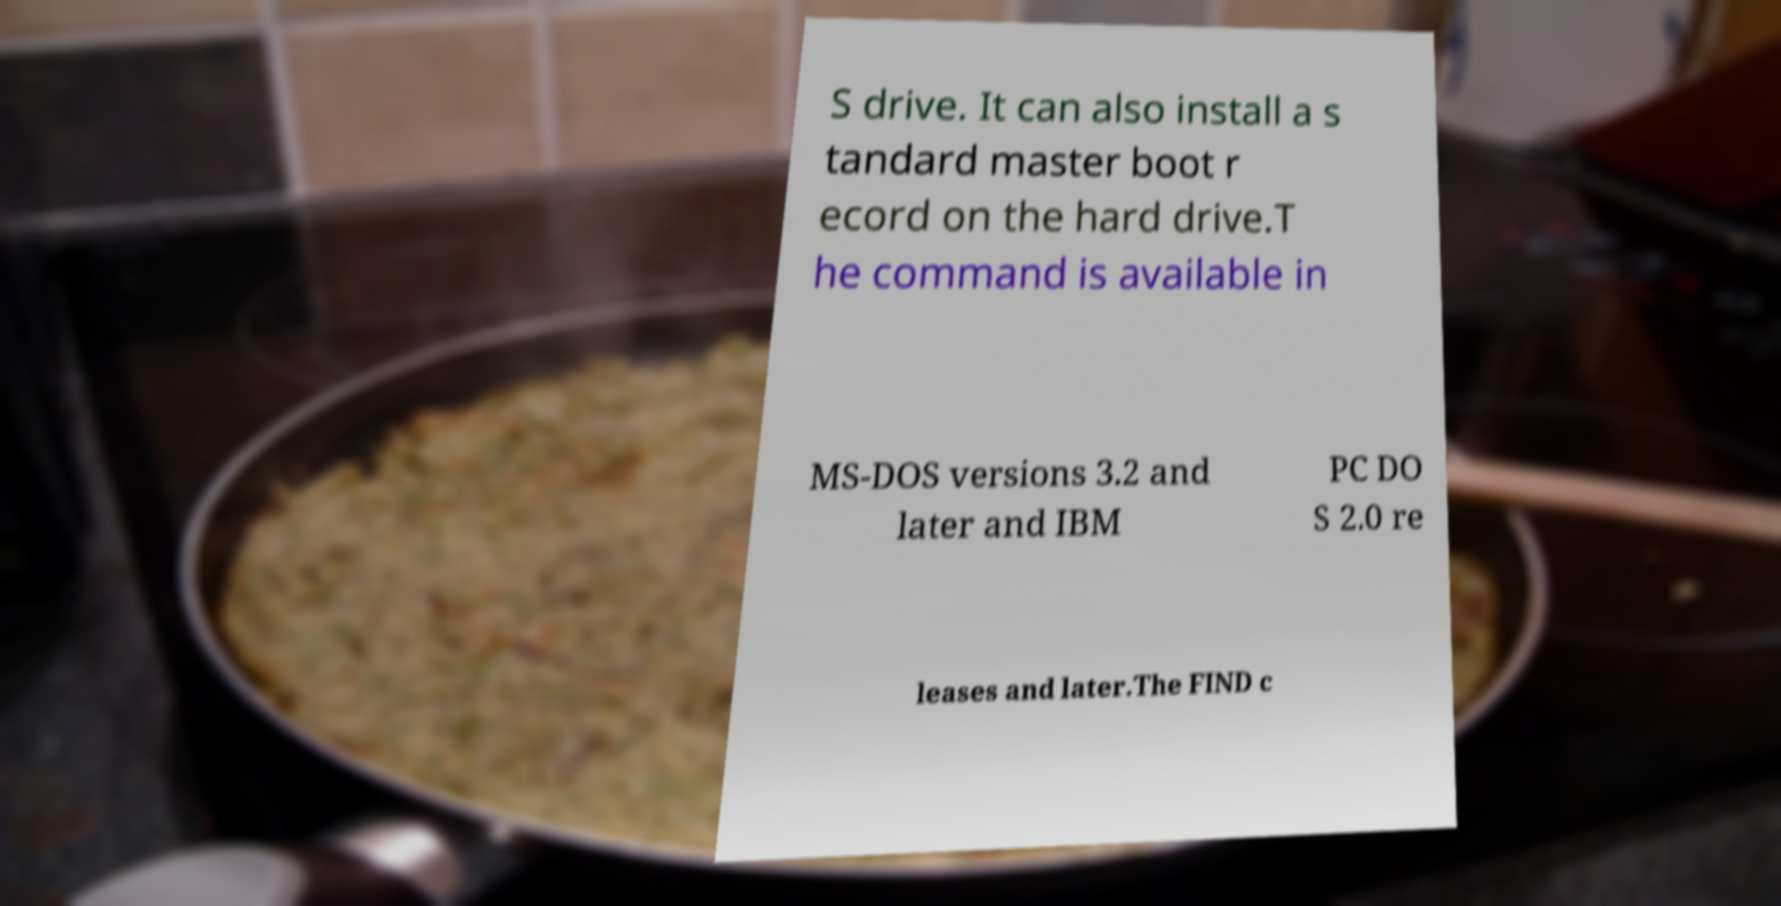For documentation purposes, I need the text within this image transcribed. Could you provide that? S drive. It can also install a s tandard master boot r ecord on the hard drive.T he command is available in MS-DOS versions 3.2 and later and IBM PC DO S 2.0 re leases and later.The FIND c 